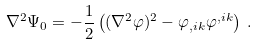Convert formula to latex. <formula><loc_0><loc_0><loc_500><loc_500>\nabla ^ { 2 } \Psi _ { 0 } = - \frac { 1 } { 2 } \left ( ( \nabla ^ { 2 } \varphi ) ^ { 2 } - \varphi _ { , i k } \varphi ^ { , i k } \right ) \, .</formula> 